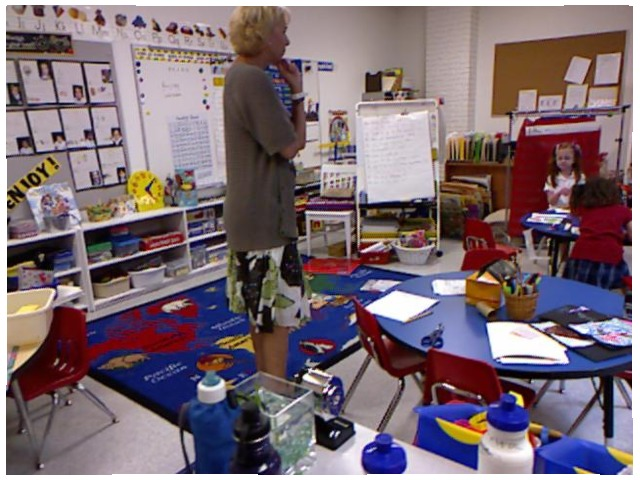<image>
Is there a child on the rug? No. The child is not positioned on the rug. They may be near each other, but the child is not supported by or resting on top of the rug. Where is the little girl in relation to the woman? Is it behind the woman? No. The little girl is not behind the woman. From this viewpoint, the little girl appears to be positioned elsewhere in the scene. 